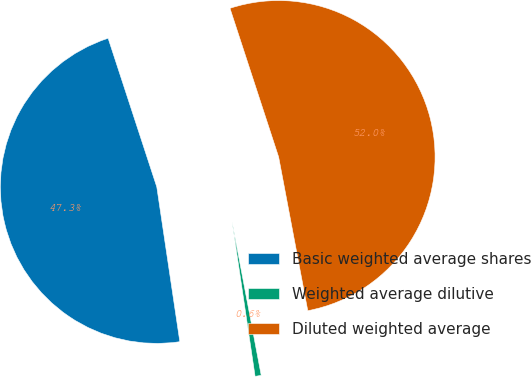Convert chart to OTSL. <chart><loc_0><loc_0><loc_500><loc_500><pie_chart><fcel>Basic weighted average shares<fcel>Weighted average dilutive<fcel>Diluted weighted average<nl><fcel>47.32%<fcel>0.63%<fcel>52.05%<nl></chart> 